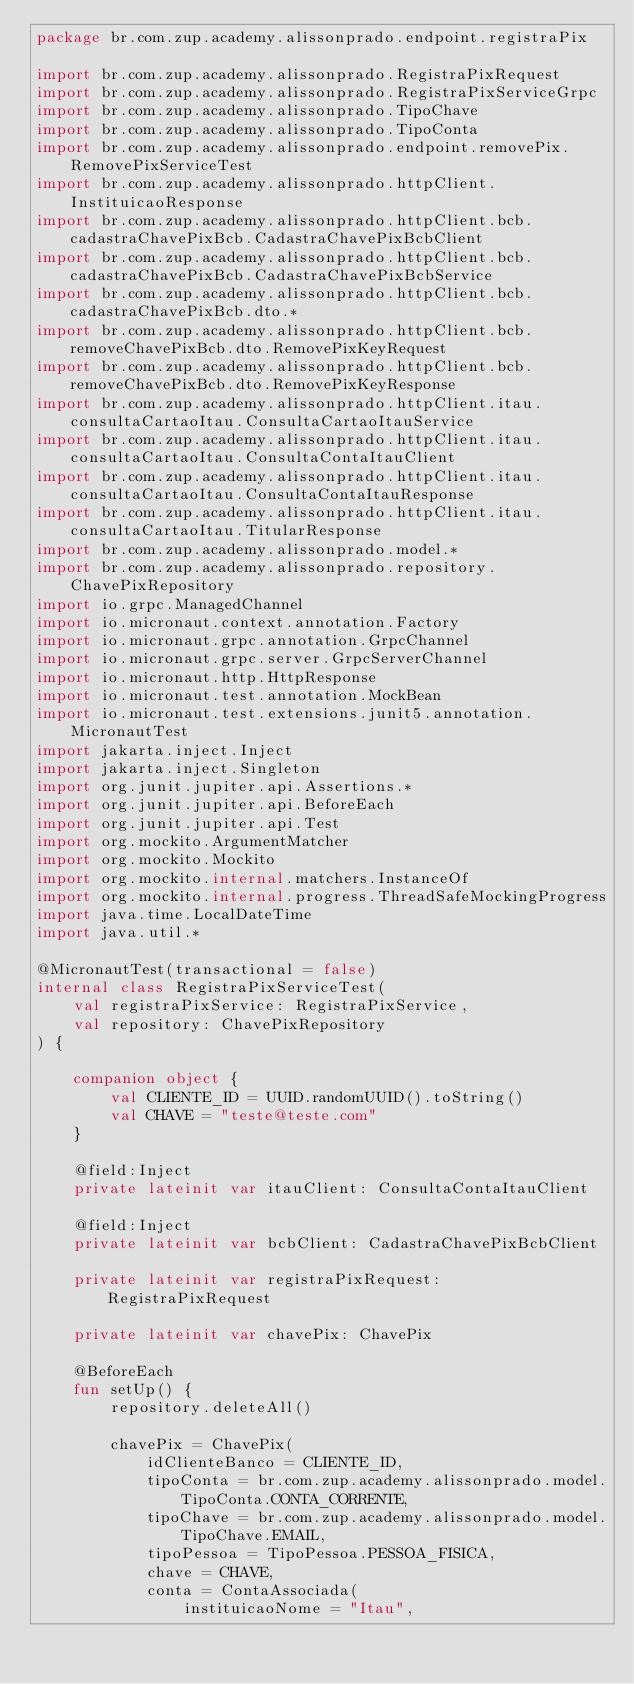<code> <loc_0><loc_0><loc_500><loc_500><_Kotlin_>package br.com.zup.academy.alissonprado.endpoint.registraPix

import br.com.zup.academy.alissonprado.RegistraPixRequest
import br.com.zup.academy.alissonprado.RegistraPixServiceGrpc
import br.com.zup.academy.alissonprado.TipoChave
import br.com.zup.academy.alissonprado.TipoConta
import br.com.zup.academy.alissonprado.endpoint.removePix.RemovePixServiceTest
import br.com.zup.academy.alissonprado.httpClient.InstituicaoResponse
import br.com.zup.academy.alissonprado.httpClient.bcb.cadastraChavePixBcb.CadastraChavePixBcbClient
import br.com.zup.academy.alissonprado.httpClient.bcb.cadastraChavePixBcb.CadastraChavePixBcbService
import br.com.zup.academy.alissonprado.httpClient.bcb.cadastraChavePixBcb.dto.*
import br.com.zup.academy.alissonprado.httpClient.bcb.removeChavePixBcb.dto.RemovePixKeyRequest
import br.com.zup.academy.alissonprado.httpClient.bcb.removeChavePixBcb.dto.RemovePixKeyResponse
import br.com.zup.academy.alissonprado.httpClient.itau.consultaCartaoItau.ConsultaCartaoItauService
import br.com.zup.academy.alissonprado.httpClient.itau.consultaCartaoItau.ConsultaContaItauClient
import br.com.zup.academy.alissonprado.httpClient.itau.consultaCartaoItau.ConsultaContaItauResponse
import br.com.zup.academy.alissonprado.httpClient.itau.consultaCartaoItau.TitularResponse
import br.com.zup.academy.alissonprado.model.*
import br.com.zup.academy.alissonprado.repository.ChavePixRepository
import io.grpc.ManagedChannel
import io.micronaut.context.annotation.Factory
import io.micronaut.grpc.annotation.GrpcChannel
import io.micronaut.grpc.server.GrpcServerChannel
import io.micronaut.http.HttpResponse
import io.micronaut.test.annotation.MockBean
import io.micronaut.test.extensions.junit5.annotation.MicronautTest
import jakarta.inject.Inject
import jakarta.inject.Singleton
import org.junit.jupiter.api.Assertions.*
import org.junit.jupiter.api.BeforeEach
import org.junit.jupiter.api.Test
import org.mockito.ArgumentMatcher
import org.mockito.Mockito
import org.mockito.internal.matchers.InstanceOf
import org.mockito.internal.progress.ThreadSafeMockingProgress
import java.time.LocalDateTime
import java.util.*

@MicronautTest(transactional = false)
internal class RegistraPixServiceTest(
    val registraPixService: RegistraPixService,
    val repository: ChavePixRepository
) {

    companion object {
        val CLIENTE_ID = UUID.randomUUID().toString()
        val CHAVE = "teste@teste.com"
    }

    @field:Inject
    private lateinit var itauClient: ConsultaContaItauClient

    @field:Inject
    private lateinit var bcbClient: CadastraChavePixBcbClient

    private lateinit var registraPixRequest: RegistraPixRequest

    private lateinit var chavePix: ChavePix

    @BeforeEach
    fun setUp() {
        repository.deleteAll()

        chavePix = ChavePix(
            idClienteBanco = CLIENTE_ID,
            tipoConta = br.com.zup.academy.alissonprado.model.TipoConta.CONTA_CORRENTE,
            tipoChave = br.com.zup.academy.alissonprado.model.TipoChave.EMAIL,
            tipoPessoa = TipoPessoa.PESSOA_FISICA,
            chave = CHAVE,
            conta = ContaAssociada(
                instituicaoNome = "Itau",</code> 